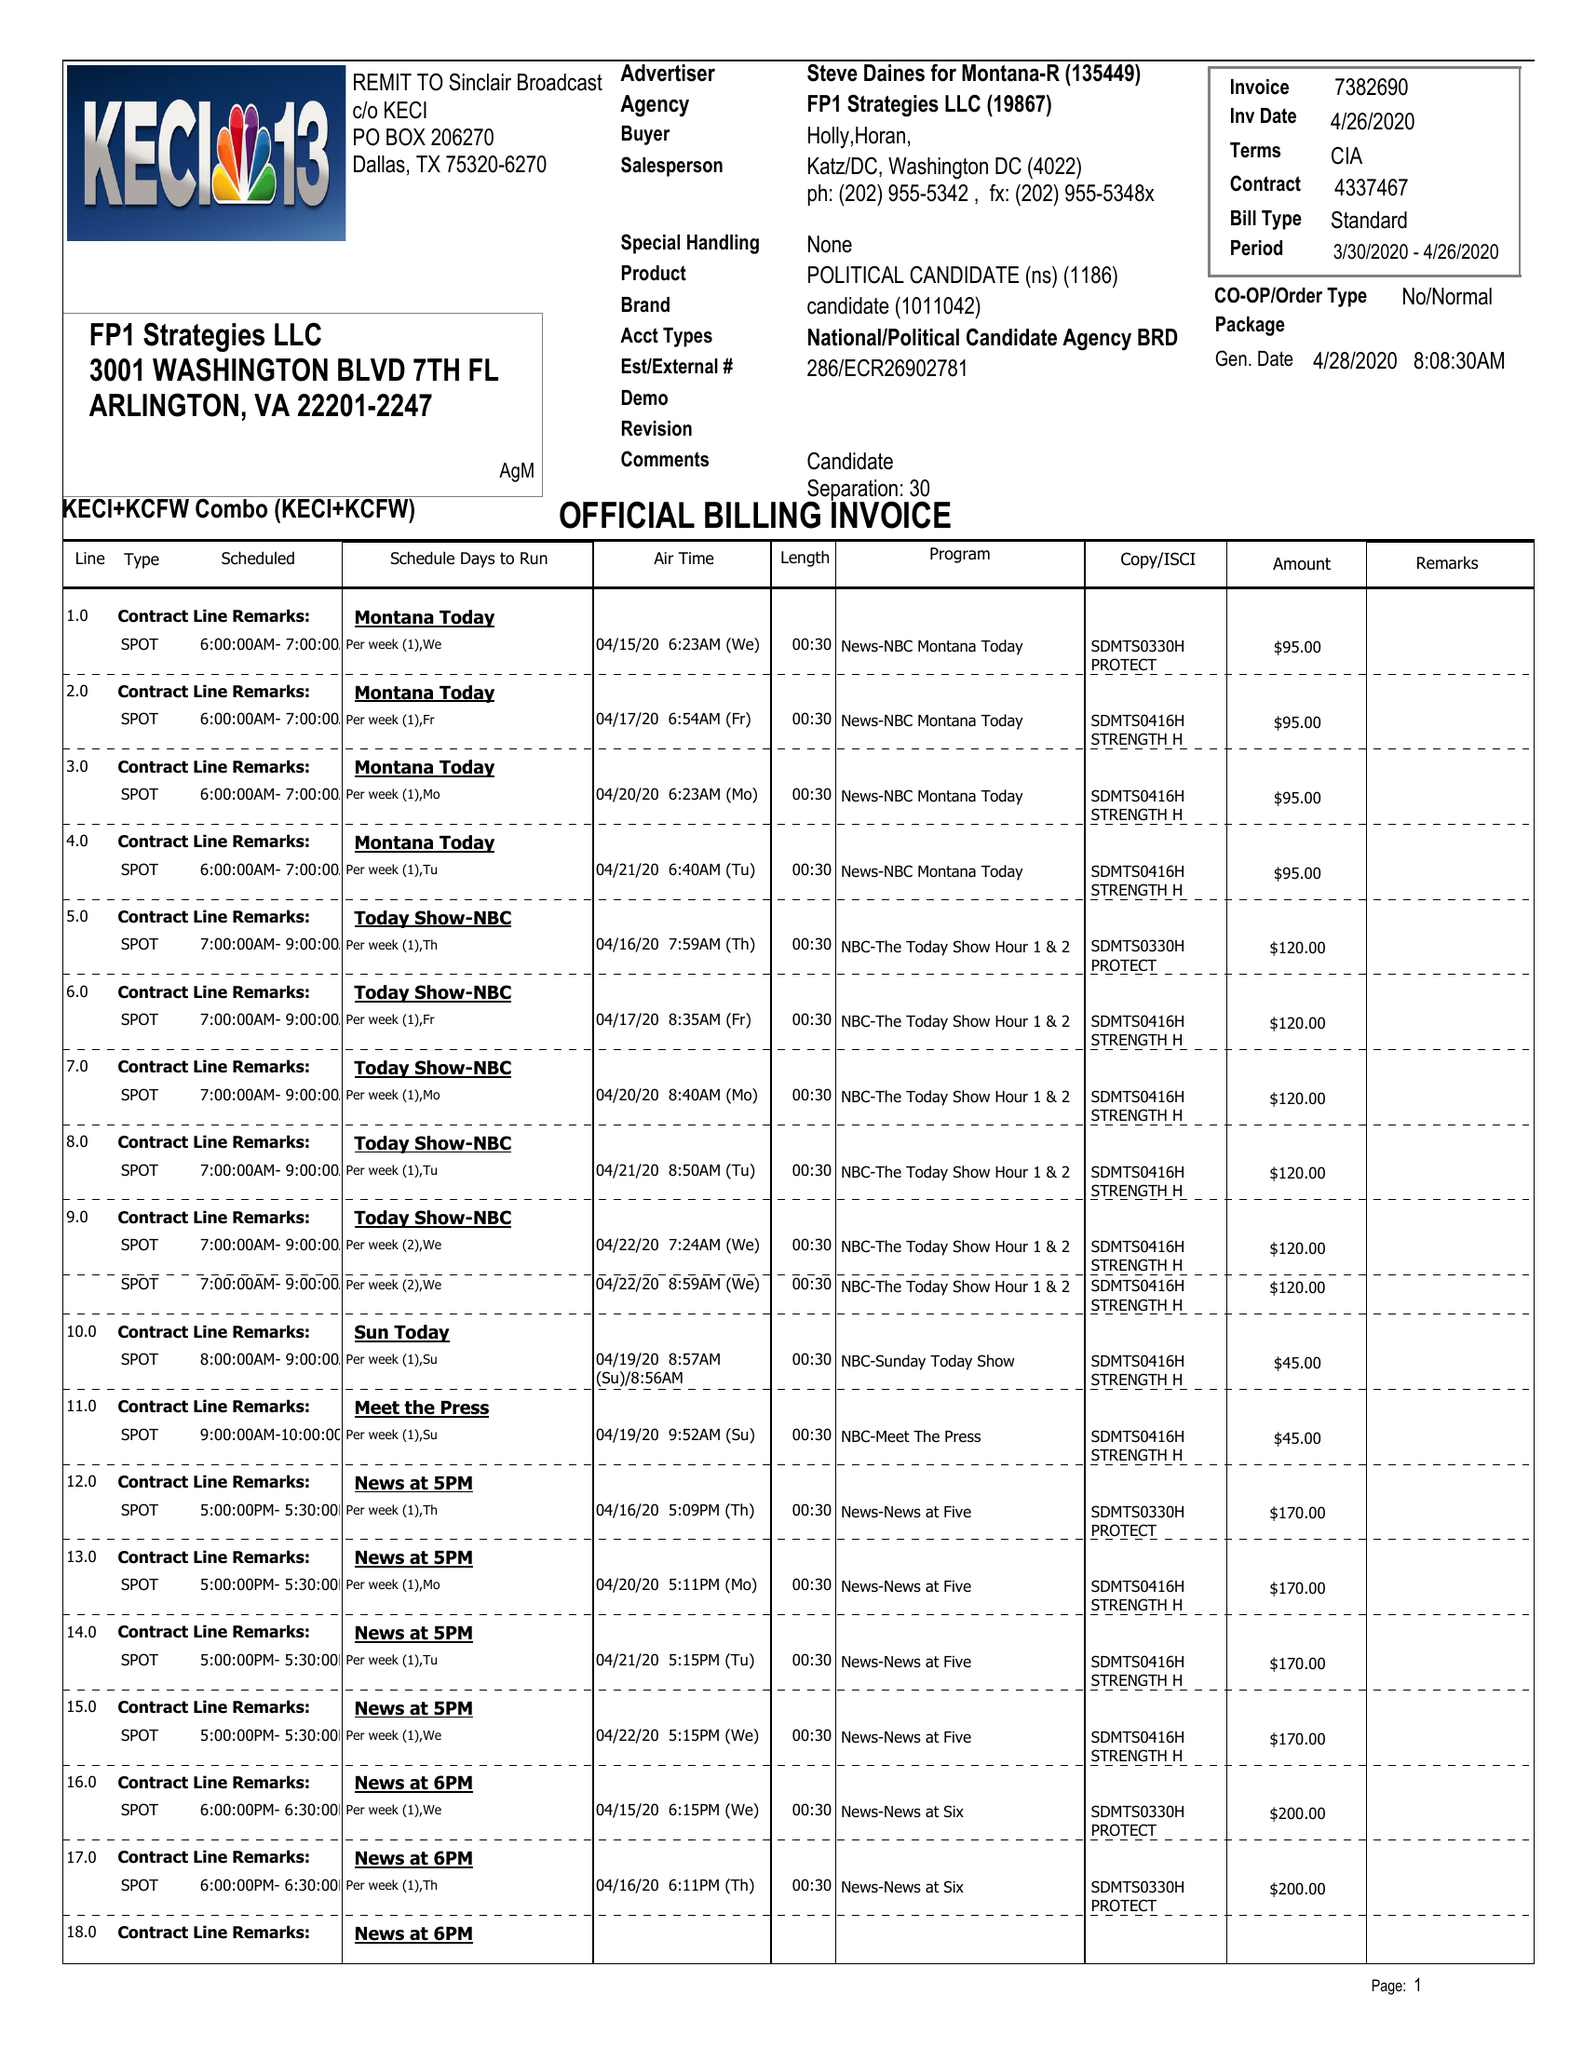What is the value for the advertiser?
Answer the question using a single word or phrase. STEVE DAINES FOR MONTANA 